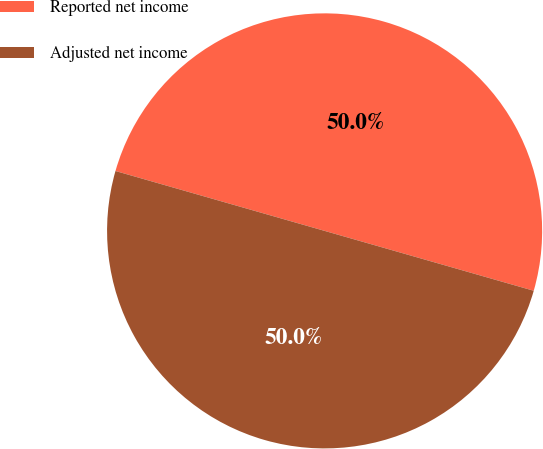Convert chart to OTSL. <chart><loc_0><loc_0><loc_500><loc_500><pie_chart><fcel>Reported net income<fcel>Adjusted net income<nl><fcel>50.0%<fcel>50.0%<nl></chart> 